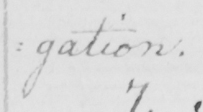What text is written in this handwritten line? : gation . 